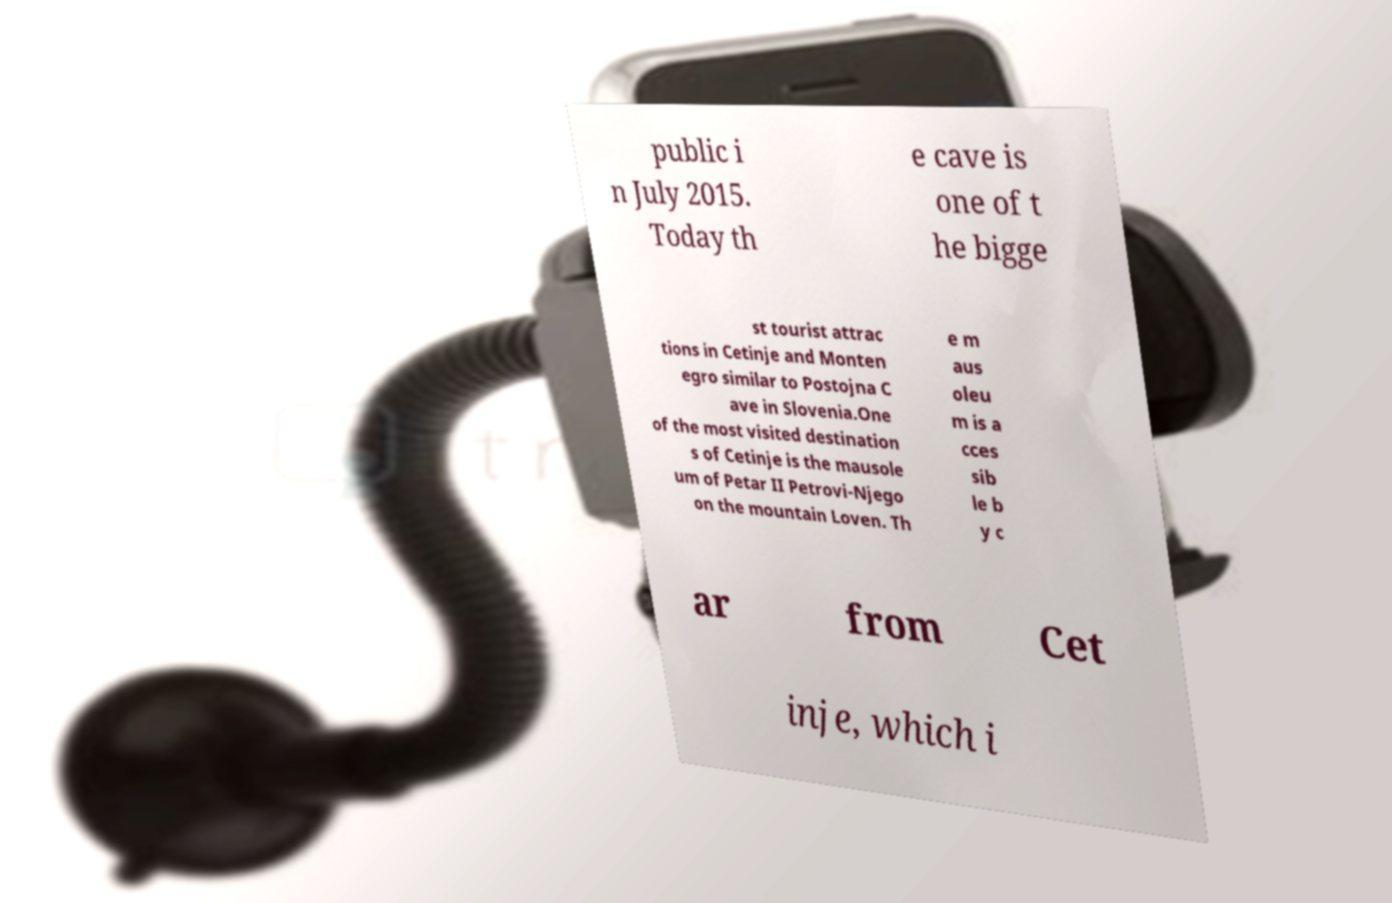Can you read and provide the text displayed in the image?This photo seems to have some interesting text. Can you extract and type it out for me? public i n July 2015. Today th e cave is one of t he bigge st tourist attrac tions in Cetinje and Monten egro similar to Postojna C ave in Slovenia.One of the most visited destination s of Cetinje is the mausole um of Petar II Petrovi-Njego on the mountain Loven. Th e m aus oleu m is a cces sib le b y c ar from Cet inje, which i 